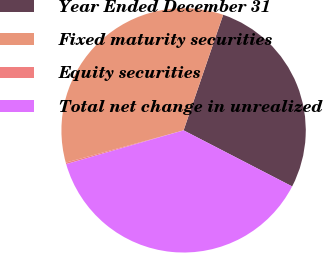<chart> <loc_0><loc_0><loc_500><loc_500><pie_chart><fcel>Year Ended December 31<fcel>Fixed maturity securities<fcel>Equity securities<fcel>Total net change in unrealized<nl><fcel>27.34%<fcel>34.51%<fcel>0.2%<fcel>37.96%<nl></chart> 